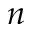Convert formula to latex. <formula><loc_0><loc_0><loc_500><loc_500>n</formula> 